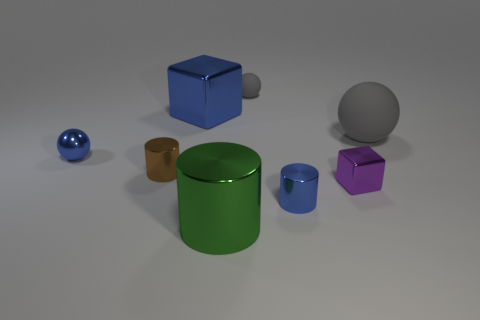Add 2 big gray rubber balls. How many objects exist? 10 Subtract all big cylinders. How many cylinders are left? 2 Subtract all gray balls. How many balls are left? 1 Subtract 0 cyan balls. How many objects are left? 8 Subtract all cylinders. How many objects are left? 5 Subtract 2 cylinders. How many cylinders are left? 1 Subtract all gray cylinders. Subtract all red cubes. How many cylinders are left? 3 Subtract all purple cylinders. How many blue spheres are left? 1 Subtract all brown shiny things. Subtract all large red cylinders. How many objects are left? 7 Add 7 big blue things. How many big blue things are left? 8 